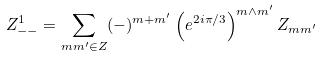Convert formula to latex. <formula><loc_0><loc_0><loc_500><loc_500>Z _ { - - } ^ { 1 } = \sum _ { m m ^ { \prime } \in Z } ( - ) ^ { m + m ^ { \prime } } \left ( e ^ { 2 i \pi / 3 } \right ) ^ { m \wedge m ^ { \prime } } Z _ { m m ^ { \prime } }</formula> 